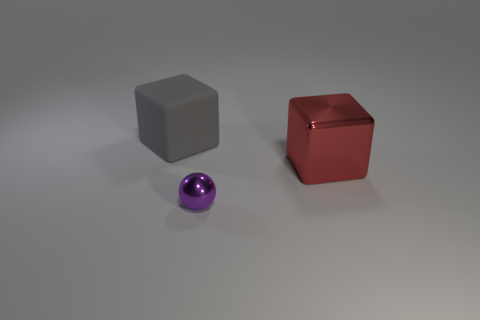Add 1 large brown cylinders. How many objects exist? 4 Subtract all blocks. How many objects are left? 1 Add 3 large purple cubes. How many large purple cubes exist? 3 Subtract 1 purple balls. How many objects are left? 2 Subtract all large gray things. Subtract all red things. How many objects are left? 1 Add 1 metallic objects. How many metallic objects are left? 3 